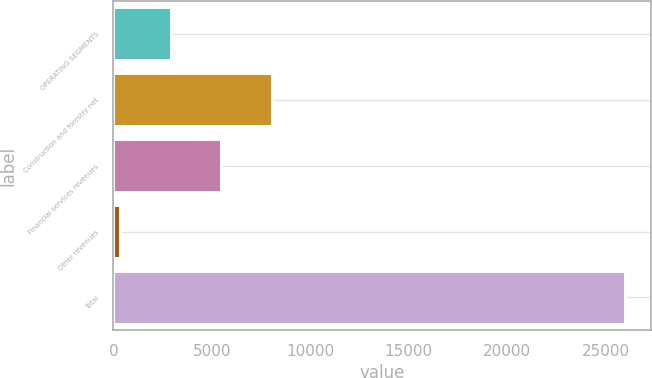<chart> <loc_0><loc_0><loc_500><loc_500><bar_chart><fcel>OPERATING SEGMENTS<fcel>Construction and forestry net<fcel>Financial services revenues<fcel>Other revenues<fcel>Total<nl><fcel>2922.7<fcel>8052.1<fcel>5487.4<fcel>358<fcel>26005<nl></chart> 